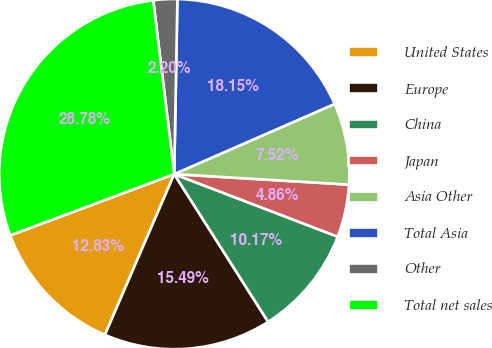<chart> <loc_0><loc_0><loc_500><loc_500><pie_chart><fcel>United States<fcel>Europe<fcel>China<fcel>Japan<fcel>Asia Other<fcel>Total Asia<fcel>Other<fcel>Total net sales<nl><fcel>12.83%<fcel>15.49%<fcel>10.17%<fcel>4.86%<fcel>7.52%<fcel>18.15%<fcel>2.2%<fcel>28.78%<nl></chart> 